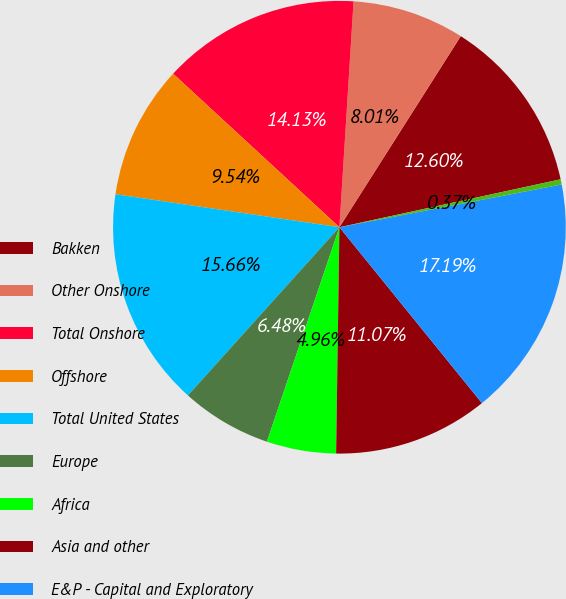Convert chart to OTSL. <chart><loc_0><loc_0><loc_500><loc_500><pie_chart><fcel>Bakken<fcel>Other Onshore<fcel>Total Onshore<fcel>Offshore<fcel>Total United States<fcel>Europe<fcel>Africa<fcel>Asia and other<fcel>E&P - Capital and Exploratory<fcel>United States<nl><fcel>12.6%<fcel>8.01%<fcel>14.13%<fcel>9.54%<fcel>15.66%<fcel>6.48%<fcel>4.96%<fcel>11.07%<fcel>17.19%<fcel>0.37%<nl></chart> 